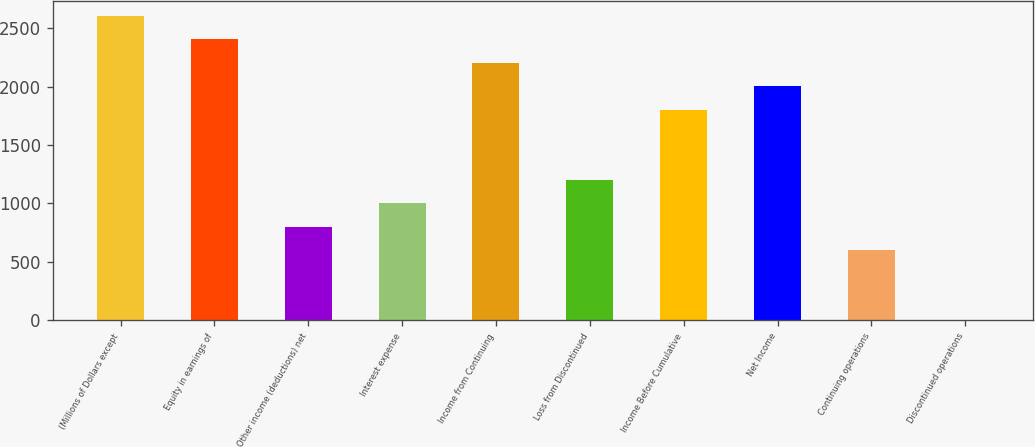Convert chart. <chart><loc_0><loc_0><loc_500><loc_500><bar_chart><fcel>(Millions of Dollars except<fcel>Equity in earnings of<fcel>Other income (deductions) net<fcel>Interest expense<fcel>Income from Continuing<fcel>Loss from Discontinued<fcel>Income Before Cumulative<fcel>Net Income<fcel>Continuing operations<fcel>Discontinued operations<nl><fcel>2603.75<fcel>2403.5<fcel>801.5<fcel>1001.75<fcel>2203.25<fcel>1202<fcel>1802.75<fcel>2003<fcel>601.25<fcel>0.5<nl></chart> 